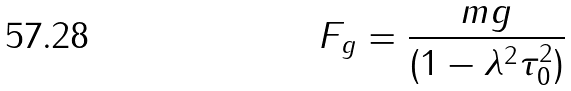<formula> <loc_0><loc_0><loc_500><loc_500>F _ { g } = \frac { m g } { ( 1 - \lambda ^ { 2 } \tau _ { 0 } ^ { 2 } ) } \</formula> 